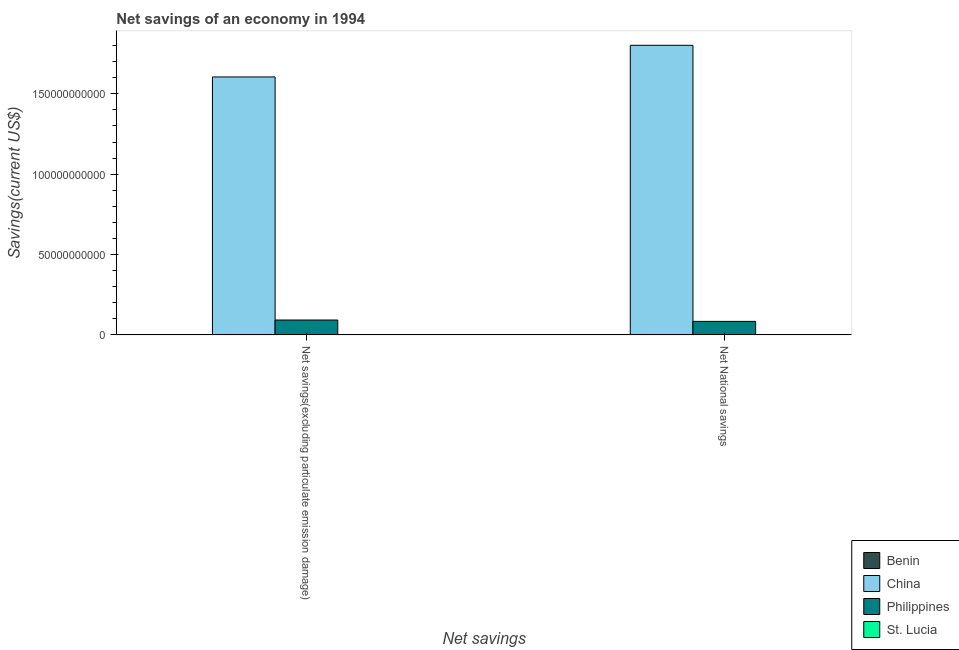How many different coloured bars are there?
Your answer should be compact. 4. How many groups of bars are there?
Give a very brief answer. 2. Are the number of bars per tick equal to the number of legend labels?
Your answer should be compact. Yes. How many bars are there on the 2nd tick from the left?
Provide a succinct answer. 4. What is the label of the 2nd group of bars from the left?
Your answer should be very brief. Net National savings. What is the net national savings in China?
Provide a succinct answer. 1.80e+11. Across all countries, what is the maximum net savings(excluding particulate emission damage)?
Give a very brief answer. 1.60e+11. Across all countries, what is the minimum net savings(excluding particulate emission damage)?
Provide a succinct answer. 7.89e+07. In which country was the net savings(excluding particulate emission damage) maximum?
Ensure brevity in your answer.  China. In which country was the net national savings minimum?
Provide a short and direct response. St. Lucia. What is the total net savings(excluding particulate emission damage) in the graph?
Provide a short and direct response. 1.70e+11. What is the difference between the net national savings in St. Lucia and that in China?
Your answer should be compact. -1.80e+11. What is the difference between the net national savings in Philippines and the net savings(excluding particulate emission damage) in St. Lucia?
Keep it short and to the point. 8.31e+09. What is the average net national savings per country?
Your response must be concise. 4.72e+1. What is the difference between the net savings(excluding particulate emission damage) and net national savings in China?
Keep it short and to the point. -1.97e+1. What is the ratio of the net savings(excluding particulate emission damage) in Philippines to that in Benin?
Keep it short and to the point. 117.17. What does the 2nd bar from the right in Net National savings represents?
Provide a short and direct response. Philippines. What is the difference between two consecutive major ticks on the Y-axis?
Your answer should be very brief. 5.00e+1. Are the values on the major ticks of Y-axis written in scientific E-notation?
Give a very brief answer. No. Does the graph contain grids?
Offer a terse response. No. How many legend labels are there?
Provide a short and direct response. 4. How are the legend labels stacked?
Keep it short and to the point. Vertical. What is the title of the graph?
Provide a succinct answer. Net savings of an economy in 1994. Does "Heavily indebted poor countries" appear as one of the legend labels in the graph?
Keep it short and to the point. No. What is the label or title of the X-axis?
Your response must be concise. Net savings. What is the label or title of the Y-axis?
Give a very brief answer. Savings(current US$). What is the Savings(current US$) of Benin in Net savings(excluding particulate emission damage)?
Make the answer very short. 7.89e+07. What is the Savings(current US$) of China in Net savings(excluding particulate emission damage)?
Your response must be concise. 1.60e+11. What is the Savings(current US$) in Philippines in Net savings(excluding particulate emission damage)?
Give a very brief answer. 9.25e+09. What is the Savings(current US$) of St. Lucia in Net savings(excluding particulate emission damage)?
Make the answer very short. 8.85e+07. What is the Savings(current US$) of Benin in Net National savings?
Your answer should be compact. 6.91e+07. What is the Savings(current US$) in China in Net National savings?
Offer a terse response. 1.80e+11. What is the Savings(current US$) in Philippines in Net National savings?
Your answer should be very brief. 8.40e+09. What is the Savings(current US$) in St. Lucia in Net National savings?
Your response must be concise. 5.98e+07. Across all Net savings, what is the maximum Savings(current US$) of Benin?
Provide a short and direct response. 7.89e+07. Across all Net savings, what is the maximum Savings(current US$) of China?
Provide a succinct answer. 1.80e+11. Across all Net savings, what is the maximum Savings(current US$) of Philippines?
Your answer should be compact. 9.25e+09. Across all Net savings, what is the maximum Savings(current US$) of St. Lucia?
Provide a short and direct response. 8.85e+07. Across all Net savings, what is the minimum Savings(current US$) of Benin?
Your answer should be very brief. 6.91e+07. Across all Net savings, what is the minimum Savings(current US$) of China?
Ensure brevity in your answer.  1.60e+11. Across all Net savings, what is the minimum Savings(current US$) in Philippines?
Provide a succinct answer. 8.40e+09. Across all Net savings, what is the minimum Savings(current US$) in St. Lucia?
Provide a short and direct response. 5.98e+07. What is the total Savings(current US$) of Benin in the graph?
Your response must be concise. 1.48e+08. What is the total Savings(current US$) in China in the graph?
Offer a very short reply. 3.41e+11. What is the total Savings(current US$) in Philippines in the graph?
Your answer should be very brief. 1.76e+1. What is the total Savings(current US$) in St. Lucia in the graph?
Your response must be concise. 1.48e+08. What is the difference between the Savings(current US$) in Benin in Net savings(excluding particulate emission damage) and that in Net National savings?
Keep it short and to the point. 9.85e+06. What is the difference between the Savings(current US$) in China in Net savings(excluding particulate emission damage) and that in Net National savings?
Provide a succinct answer. -1.97e+1. What is the difference between the Savings(current US$) of Philippines in Net savings(excluding particulate emission damage) and that in Net National savings?
Offer a terse response. 8.49e+08. What is the difference between the Savings(current US$) of St. Lucia in Net savings(excluding particulate emission damage) and that in Net National savings?
Offer a very short reply. 2.87e+07. What is the difference between the Savings(current US$) in Benin in Net savings(excluding particulate emission damage) and the Savings(current US$) in China in Net National savings?
Make the answer very short. -1.80e+11. What is the difference between the Savings(current US$) of Benin in Net savings(excluding particulate emission damage) and the Savings(current US$) of Philippines in Net National savings?
Make the answer very short. -8.32e+09. What is the difference between the Savings(current US$) in Benin in Net savings(excluding particulate emission damage) and the Savings(current US$) in St. Lucia in Net National savings?
Make the answer very short. 1.92e+07. What is the difference between the Savings(current US$) of China in Net savings(excluding particulate emission damage) and the Savings(current US$) of Philippines in Net National savings?
Your answer should be compact. 1.52e+11. What is the difference between the Savings(current US$) of China in Net savings(excluding particulate emission damage) and the Savings(current US$) of St. Lucia in Net National savings?
Offer a terse response. 1.60e+11. What is the difference between the Savings(current US$) in Philippines in Net savings(excluding particulate emission damage) and the Savings(current US$) in St. Lucia in Net National savings?
Keep it short and to the point. 9.19e+09. What is the average Savings(current US$) of Benin per Net savings?
Your response must be concise. 7.40e+07. What is the average Savings(current US$) of China per Net savings?
Offer a very short reply. 1.70e+11. What is the average Savings(current US$) of Philippines per Net savings?
Your answer should be very brief. 8.82e+09. What is the average Savings(current US$) of St. Lucia per Net savings?
Make the answer very short. 7.41e+07. What is the difference between the Savings(current US$) of Benin and Savings(current US$) of China in Net savings(excluding particulate emission damage)?
Your response must be concise. -1.60e+11. What is the difference between the Savings(current US$) in Benin and Savings(current US$) in Philippines in Net savings(excluding particulate emission damage)?
Give a very brief answer. -9.17e+09. What is the difference between the Savings(current US$) in Benin and Savings(current US$) in St. Lucia in Net savings(excluding particulate emission damage)?
Give a very brief answer. -9.58e+06. What is the difference between the Savings(current US$) of China and Savings(current US$) of Philippines in Net savings(excluding particulate emission damage)?
Offer a terse response. 1.51e+11. What is the difference between the Savings(current US$) of China and Savings(current US$) of St. Lucia in Net savings(excluding particulate emission damage)?
Offer a terse response. 1.60e+11. What is the difference between the Savings(current US$) of Philippines and Savings(current US$) of St. Lucia in Net savings(excluding particulate emission damage)?
Provide a succinct answer. 9.16e+09. What is the difference between the Savings(current US$) in Benin and Savings(current US$) in China in Net National savings?
Offer a very short reply. -1.80e+11. What is the difference between the Savings(current US$) in Benin and Savings(current US$) in Philippines in Net National savings?
Give a very brief answer. -8.33e+09. What is the difference between the Savings(current US$) of Benin and Savings(current US$) of St. Lucia in Net National savings?
Provide a succinct answer. 9.31e+06. What is the difference between the Savings(current US$) in China and Savings(current US$) in Philippines in Net National savings?
Keep it short and to the point. 1.72e+11. What is the difference between the Savings(current US$) of China and Savings(current US$) of St. Lucia in Net National savings?
Your response must be concise. 1.80e+11. What is the difference between the Savings(current US$) in Philippines and Savings(current US$) in St. Lucia in Net National savings?
Make the answer very short. 8.34e+09. What is the ratio of the Savings(current US$) in Benin in Net savings(excluding particulate emission damage) to that in Net National savings?
Offer a very short reply. 1.14. What is the ratio of the Savings(current US$) of China in Net savings(excluding particulate emission damage) to that in Net National savings?
Your answer should be very brief. 0.89. What is the ratio of the Savings(current US$) in Philippines in Net savings(excluding particulate emission damage) to that in Net National savings?
Your answer should be compact. 1.1. What is the ratio of the Savings(current US$) in St. Lucia in Net savings(excluding particulate emission damage) to that in Net National savings?
Your answer should be compact. 1.48. What is the difference between the highest and the second highest Savings(current US$) in Benin?
Keep it short and to the point. 9.85e+06. What is the difference between the highest and the second highest Savings(current US$) of China?
Your answer should be very brief. 1.97e+1. What is the difference between the highest and the second highest Savings(current US$) in Philippines?
Your answer should be very brief. 8.49e+08. What is the difference between the highest and the second highest Savings(current US$) of St. Lucia?
Your answer should be very brief. 2.87e+07. What is the difference between the highest and the lowest Savings(current US$) of Benin?
Offer a very short reply. 9.85e+06. What is the difference between the highest and the lowest Savings(current US$) of China?
Offer a terse response. 1.97e+1. What is the difference between the highest and the lowest Savings(current US$) in Philippines?
Offer a terse response. 8.49e+08. What is the difference between the highest and the lowest Savings(current US$) in St. Lucia?
Your answer should be compact. 2.87e+07. 